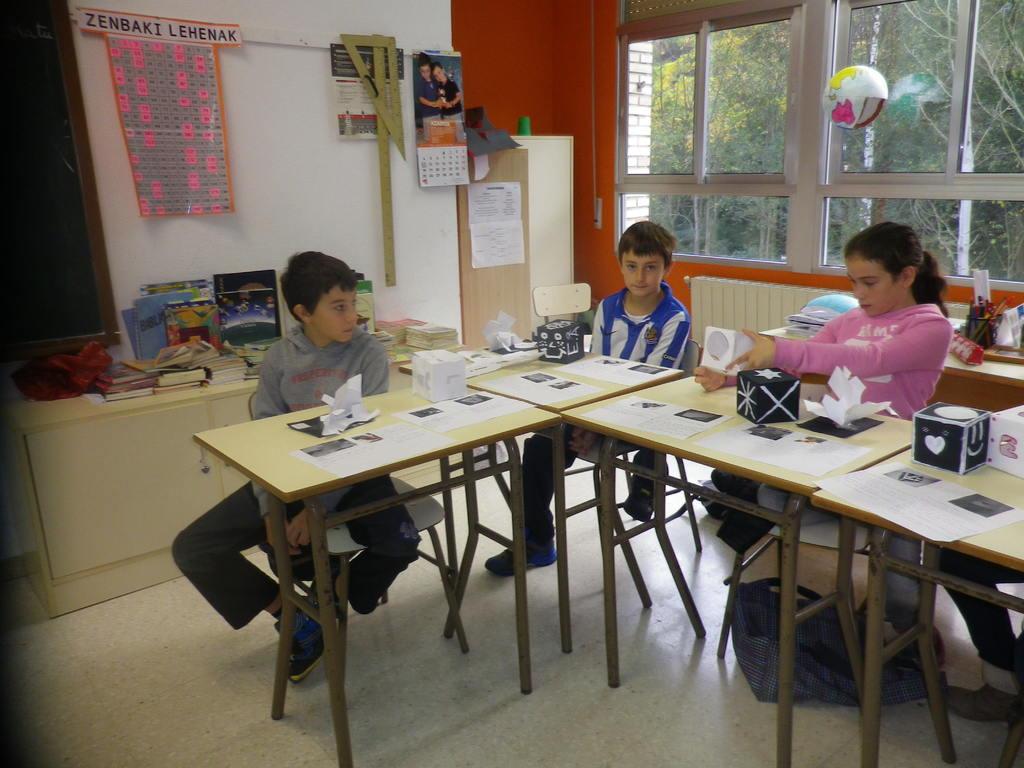In one or two sentences, can you explain what this image depicts? A picture of a classroom. A blackboard, chart, scale and calendar is on wall. In-front of this blackboard there is a table, on this table there are books. These three kids are sitting on a chair. In-front of them there are tables. On this tables there are papers and boxes. This girl is holding a box. This boy is staring at this girl. From this window we can able to see trees. At the corner of the room there is a cupboard with poster. Under the table there is a bag. 